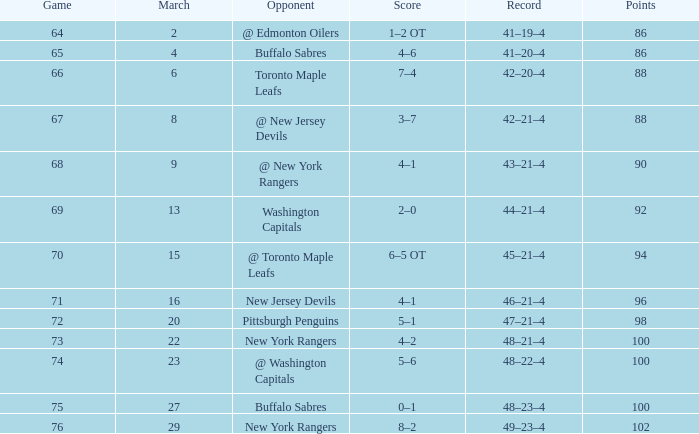In which march with a score of 5-6 can the lowest points be found, less than 100? None. Write the full table. {'header': ['Game', 'March', 'Opponent', 'Score', 'Record', 'Points'], 'rows': [['64', '2', '@ Edmonton Oilers', '1–2 OT', '41–19–4', '86'], ['65', '4', 'Buffalo Sabres', '4–6', '41–20–4', '86'], ['66', '6', 'Toronto Maple Leafs', '7–4', '42–20–4', '88'], ['67', '8', '@ New Jersey Devils', '3–7', '42–21–4', '88'], ['68', '9', '@ New York Rangers', '4–1', '43–21–4', '90'], ['69', '13', 'Washington Capitals', '2–0', '44–21–4', '92'], ['70', '15', '@ Toronto Maple Leafs', '6–5 OT', '45–21–4', '94'], ['71', '16', 'New Jersey Devils', '4–1', '46–21–4', '96'], ['72', '20', 'Pittsburgh Penguins', '5–1', '47–21–4', '98'], ['73', '22', 'New York Rangers', '4–2', '48–21–4', '100'], ['74', '23', '@ Washington Capitals', '5–6', '48–22–4', '100'], ['75', '27', 'Buffalo Sabres', '0–1', '48–23–4', '100'], ['76', '29', 'New York Rangers', '8–2', '49–23–4', '102']]} 